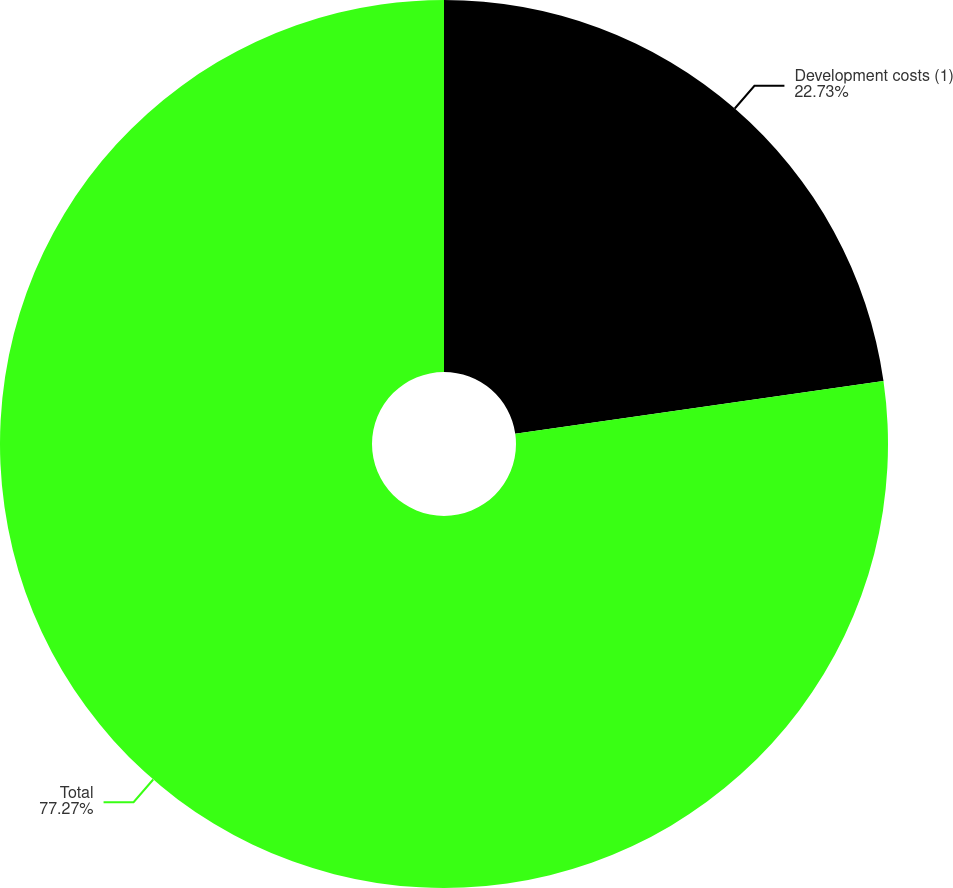<chart> <loc_0><loc_0><loc_500><loc_500><pie_chart><fcel>Development costs (1)<fcel>Total<nl><fcel>22.73%<fcel>77.27%<nl></chart> 